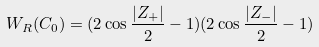Convert formula to latex. <formula><loc_0><loc_0><loc_500><loc_500>W _ { R } ( C _ { 0 } ) = ( 2 \cos \frac { | Z _ { + } | } { 2 } - 1 ) ( 2 \cos \frac { | Z _ { - } | } { 2 } - 1 )</formula> 